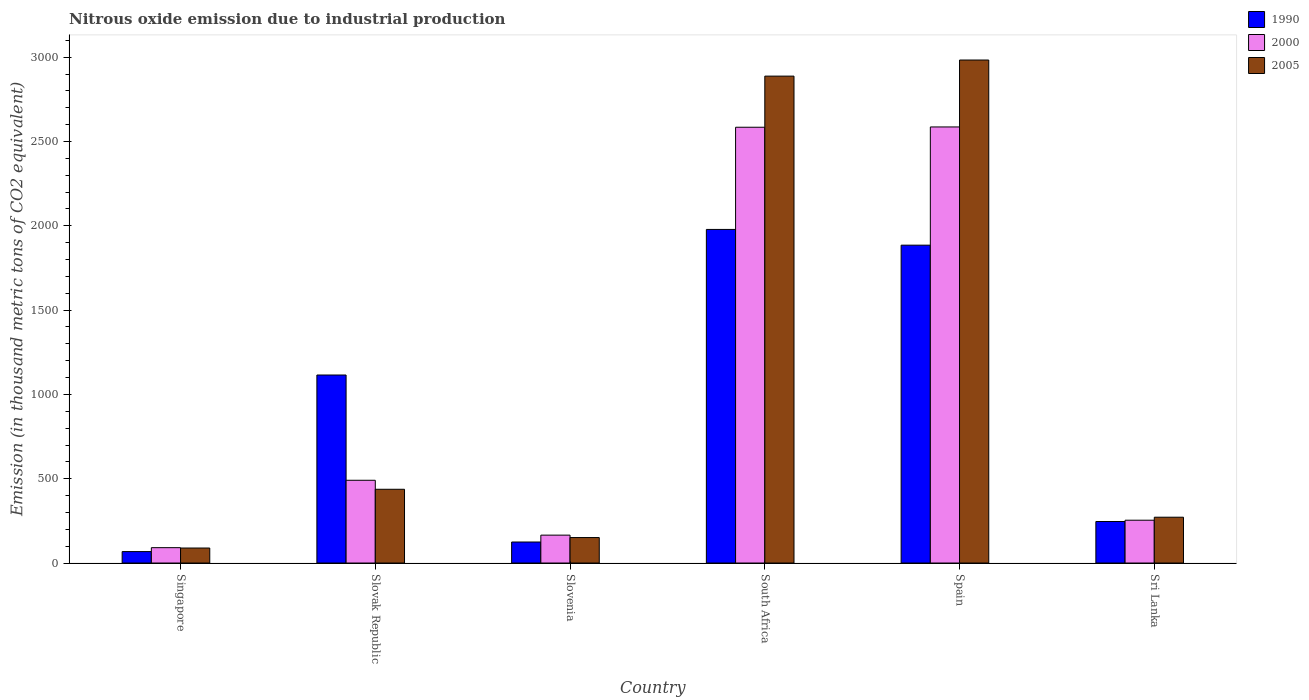How many groups of bars are there?
Provide a short and direct response. 6. Are the number of bars per tick equal to the number of legend labels?
Your response must be concise. Yes. How many bars are there on the 6th tick from the left?
Your response must be concise. 3. What is the label of the 3rd group of bars from the left?
Your response must be concise. Slovenia. In how many cases, is the number of bars for a given country not equal to the number of legend labels?
Offer a very short reply. 0. What is the amount of nitrous oxide emitted in 1990 in Slovenia?
Keep it short and to the point. 124.7. Across all countries, what is the maximum amount of nitrous oxide emitted in 2005?
Your answer should be very brief. 2983.4. Across all countries, what is the minimum amount of nitrous oxide emitted in 2005?
Make the answer very short. 89. In which country was the amount of nitrous oxide emitted in 1990 maximum?
Your answer should be compact. South Africa. In which country was the amount of nitrous oxide emitted in 2000 minimum?
Provide a succinct answer. Singapore. What is the total amount of nitrous oxide emitted in 2000 in the graph?
Offer a very short reply. 6172.6. What is the difference between the amount of nitrous oxide emitted in 2005 in Slovak Republic and that in Sri Lanka?
Your answer should be very brief. 165.7. What is the difference between the amount of nitrous oxide emitted in 2000 in South Africa and the amount of nitrous oxide emitted in 2005 in Spain?
Offer a very short reply. -398.7. What is the average amount of nitrous oxide emitted in 1990 per country?
Offer a terse response. 903. What is the ratio of the amount of nitrous oxide emitted in 2000 in South Africa to that in Sri Lanka?
Your answer should be very brief. 10.18. Is the amount of nitrous oxide emitted in 1990 in Singapore less than that in Slovenia?
Offer a terse response. Yes. What is the difference between the highest and the second highest amount of nitrous oxide emitted in 1990?
Make the answer very short. 863.4. What is the difference between the highest and the lowest amount of nitrous oxide emitted in 2005?
Provide a succinct answer. 2894.4. Is the sum of the amount of nitrous oxide emitted in 2000 in Slovenia and South Africa greater than the maximum amount of nitrous oxide emitted in 2005 across all countries?
Provide a succinct answer. No. What does the 3rd bar from the right in Sri Lanka represents?
Make the answer very short. 1990. How many bars are there?
Provide a short and direct response. 18. Are all the bars in the graph horizontal?
Ensure brevity in your answer.  No. How many countries are there in the graph?
Ensure brevity in your answer.  6. Are the values on the major ticks of Y-axis written in scientific E-notation?
Your answer should be compact. No. Does the graph contain any zero values?
Your answer should be very brief. No. Where does the legend appear in the graph?
Offer a terse response. Top right. How are the legend labels stacked?
Offer a terse response. Vertical. What is the title of the graph?
Offer a terse response. Nitrous oxide emission due to industrial production. What is the label or title of the Y-axis?
Make the answer very short. Emission (in thousand metric tons of CO2 equivalent). What is the Emission (in thousand metric tons of CO2 equivalent) in 1990 in Singapore?
Offer a very short reply. 67.9. What is the Emission (in thousand metric tons of CO2 equivalent) of 2000 in Singapore?
Give a very brief answer. 91.1. What is the Emission (in thousand metric tons of CO2 equivalent) in 2005 in Singapore?
Give a very brief answer. 89. What is the Emission (in thousand metric tons of CO2 equivalent) of 1990 in Slovak Republic?
Offer a terse response. 1115.2. What is the Emission (in thousand metric tons of CO2 equivalent) of 2000 in Slovak Republic?
Offer a terse response. 490.8. What is the Emission (in thousand metric tons of CO2 equivalent) in 2005 in Slovak Republic?
Keep it short and to the point. 437.5. What is the Emission (in thousand metric tons of CO2 equivalent) of 1990 in Slovenia?
Your answer should be very brief. 124.7. What is the Emission (in thousand metric tons of CO2 equivalent) of 2000 in Slovenia?
Make the answer very short. 165.5. What is the Emission (in thousand metric tons of CO2 equivalent) of 2005 in Slovenia?
Provide a succinct answer. 151.1. What is the Emission (in thousand metric tons of CO2 equivalent) of 1990 in South Africa?
Your response must be concise. 1978.6. What is the Emission (in thousand metric tons of CO2 equivalent) of 2000 in South Africa?
Give a very brief answer. 2584.7. What is the Emission (in thousand metric tons of CO2 equivalent) of 2005 in South Africa?
Make the answer very short. 2888. What is the Emission (in thousand metric tons of CO2 equivalent) in 1990 in Spain?
Your response must be concise. 1885.3. What is the Emission (in thousand metric tons of CO2 equivalent) of 2000 in Spain?
Your response must be concise. 2586.5. What is the Emission (in thousand metric tons of CO2 equivalent) of 2005 in Spain?
Your response must be concise. 2983.4. What is the Emission (in thousand metric tons of CO2 equivalent) in 1990 in Sri Lanka?
Offer a terse response. 246.3. What is the Emission (in thousand metric tons of CO2 equivalent) in 2000 in Sri Lanka?
Provide a short and direct response. 254. What is the Emission (in thousand metric tons of CO2 equivalent) of 2005 in Sri Lanka?
Provide a short and direct response. 271.8. Across all countries, what is the maximum Emission (in thousand metric tons of CO2 equivalent) in 1990?
Keep it short and to the point. 1978.6. Across all countries, what is the maximum Emission (in thousand metric tons of CO2 equivalent) in 2000?
Your answer should be very brief. 2586.5. Across all countries, what is the maximum Emission (in thousand metric tons of CO2 equivalent) of 2005?
Your answer should be compact. 2983.4. Across all countries, what is the minimum Emission (in thousand metric tons of CO2 equivalent) in 1990?
Provide a succinct answer. 67.9. Across all countries, what is the minimum Emission (in thousand metric tons of CO2 equivalent) of 2000?
Keep it short and to the point. 91.1. Across all countries, what is the minimum Emission (in thousand metric tons of CO2 equivalent) of 2005?
Give a very brief answer. 89. What is the total Emission (in thousand metric tons of CO2 equivalent) in 1990 in the graph?
Provide a short and direct response. 5418. What is the total Emission (in thousand metric tons of CO2 equivalent) in 2000 in the graph?
Keep it short and to the point. 6172.6. What is the total Emission (in thousand metric tons of CO2 equivalent) in 2005 in the graph?
Provide a short and direct response. 6820.8. What is the difference between the Emission (in thousand metric tons of CO2 equivalent) of 1990 in Singapore and that in Slovak Republic?
Make the answer very short. -1047.3. What is the difference between the Emission (in thousand metric tons of CO2 equivalent) of 2000 in Singapore and that in Slovak Republic?
Offer a terse response. -399.7. What is the difference between the Emission (in thousand metric tons of CO2 equivalent) in 2005 in Singapore and that in Slovak Republic?
Your answer should be very brief. -348.5. What is the difference between the Emission (in thousand metric tons of CO2 equivalent) of 1990 in Singapore and that in Slovenia?
Offer a very short reply. -56.8. What is the difference between the Emission (in thousand metric tons of CO2 equivalent) in 2000 in Singapore and that in Slovenia?
Give a very brief answer. -74.4. What is the difference between the Emission (in thousand metric tons of CO2 equivalent) of 2005 in Singapore and that in Slovenia?
Your response must be concise. -62.1. What is the difference between the Emission (in thousand metric tons of CO2 equivalent) in 1990 in Singapore and that in South Africa?
Your answer should be compact. -1910.7. What is the difference between the Emission (in thousand metric tons of CO2 equivalent) of 2000 in Singapore and that in South Africa?
Your response must be concise. -2493.6. What is the difference between the Emission (in thousand metric tons of CO2 equivalent) in 2005 in Singapore and that in South Africa?
Offer a terse response. -2799. What is the difference between the Emission (in thousand metric tons of CO2 equivalent) in 1990 in Singapore and that in Spain?
Make the answer very short. -1817.4. What is the difference between the Emission (in thousand metric tons of CO2 equivalent) in 2000 in Singapore and that in Spain?
Offer a very short reply. -2495.4. What is the difference between the Emission (in thousand metric tons of CO2 equivalent) in 2005 in Singapore and that in Spain?
Offer a very short reply. -2894.4. What is the difference between the Emission (in thousand metric tons of CO2 equivalent) of 1990 in Singapore and that in Sri Lanka?
Your response must be concise. -178.4. What is the difference between the Emission (in thousand metric tons of CO2 equivalent) in 2000 in Singapore and that in Sri Lanka?
Provide a succinct answer. -162.9. What is the difference between the Emission (in thousand metric tons of CO2 equivalent) in 2005 in Singapore and that in Sri Lanka?
Keep it short and to the point. -182.8. What is the difference between the Emission (in thousand metric tons of CO2 equivalent) of 1990 in Slovak Republic and that in Slovenia?
Give a very brief answer. 990.5. What is the difference between the Emission (in thousand metric tons of CO2 equivalent) in 2000 in Slovak Republic and that in Slovenia?
Keep it short and to the point. 325.3. What is the difference between the Emission (in thousand metric tons of CO2 equivalent) in 2005 in Slovak Republic and that in Slovenia?
Provide a short and direct response. 286.4. What is the difference between the Emission (in thousand metric tons of CO2 equivalent) in 1990 in Slovak Republic and that in South Africa?
Offer a terse response. -863.4. What is the difference between the Emission (in thousand metric tons of CO2 equivalent) in 2000 in Slovak Republic and that in South Africa?
Your response must be concise. -2093.9. What is the difference between the Emission (in thousand metric tons of CO2 equivalent) of 2005 in Slovak Republic and that in South Africa?
Offer a terse response. -2450.5. What is the difference between the Emission (in thousand metric tons of CO2 equivalent) of 1990 in Slovak Republic and that in Spain?
Offer a very short reply. -770.1. What is the difference between the Emission (in thousand metric tons of CO2 equivalent) in 2000 in Slovak Republic and that in Spain?
Ensure brevity in your answer.  -2095.7. What is the difference between the Emission (in thousand metric tons of CO2 equivalent) of 2005 in Slovak Republic and that in Spain?
Offer a terse response. -2545.9. What is the difference between the Emission (in thousand metric tons of CO2 equivalent) in 1990 in Slovak Republic and that in Sri Lanka?
Your answer should be compact. 868.9. What is the difference between the Emission (in thousand metric tons of CO2 equivalent) of 2000 in Slovak Republic and that in Sri Lanka?
Make the answer very short. 236.8. What is the difference between the Emission (in thousand metric tons of CO2 equivalent) in 2005 in Slovak Republic and that in Sri Lanka?
Your response must be concise. 165.7. What is the difference between the Emission (in thousand metric tons of CO2 equivalent) in 1990 in Slovenia and that in South Africa?
Provide a short and direct response. -1853.9. What is the difference between the Emission (in thousand metric tons of CO2 equivalent) of 2000 in Slovenia and that in South Africa?
Provide a succinct answer. -2419.2. What is the difference between the Emission (in thousand metric tons of CO2 equivalent) in 2005 in Slovenia and that in South Africa?
Give a very brief answer. -2736.9. What is the difference between the Emission (in thousand metric tons of CO2 equivalent) of 1990 in Slovenia and that in Spain?
Offer a terse response. -1760.6. What is the difference between the Emission (in thousand metric tons of CO2 equivalent) in 2000 in Slovenia and that in Spain?
Keep it short and to the point. -2421. What is the difference between the Emission (in thousand metric tons of CO2 equivalent) of 2005 in Slovenia and that in Spain?
Provide a succinct answer. -2832.3. What is the difference between the Emission (in thousand metric tons of CO2 equivalent) in 1990 in Slovenia and that in Sri Lanka?
Your response must be concise. -121.6. What is the difference between the Emission (in thousand metric tons of CO2 equivalent) of 2000 in Slovenia and that in Sri Lanka?
Give a very brief answer. -88.5. What is the difference between the Emission (in thousand metric tons of CO2 equivalent) in 2005 in Slovenia and that in Sri Lanka?
Your response must be concise. -120.7. What is the difference between the Emission (in thousand metric tons of CO2 equivalent) of 1990 in South Africa and that in Spain?
Make the answer very short. 93.3. What is the difference between the Emission (in thousand metric tons of CO2 equivalent) of 2005 in South Africa and that in Spain?
Ensure brevity in your answer.  -95.4. What is the difference between the Emission (in thousand metric tons of CO2 equivalent) of 1990 in South Africa and that in Sri Lanka?
Give a very brief answer. 1732.3. What is the difference between the Emission (in thousand metric tons of CO2 equivalent) of 2000 in South Africa and that in Sri Lanka?
Offer a terse response. 2330.7. What is the difference between the Emission (in thousand metric tons of CO2 equivalent) of 2005 in South Africa and that in Sri Lanka?
Offer a terse response. 2616.2. What is the difference between the Emission (in thousand metric tons of CO2 equivalent) in 1990 in Spain and that in Sri Lanka?
Your response must be concise. 1639. What is the difference between the Emission (in thousand metric tons of CO2 equivalent) of 2000 in Spain and that in Sri Lanka?
Your response must be concise. 2332.5. What is the difference between the Emission (in thousand metric tons of CO2 equivalent) in 2005 in Spain and that in Sri Lanka?
Keep it short and to the point. 2711.6. What is the difference between the Emission (in thousand metric tons of CO2 equivalent) of 1990 in Singapore and the Emission (in thousand metric tons of CO2 equivalent) of 2000 in Slovak Republic?
Offer a very short reply. -422.9. What is the difference between the Emission (in thousand metric tons of CO2 equivalent) in 1990 in Singapore and the Emission (in thousand metric tons of CO2 equivalent) in 2005 in Slovak Republic?
Provide a short and direct response. -369.6. What is the difference between the Emission (in thousand metric tons of CO2 equivalent) of 2000 in Singapore and the Emission (in thousand metric tons of CO2 equivalent) of 2005 in Slovak Republic?
Your response must be concise. -346.4. What is the difference between the Emission (in thousand metric tons of CO2 equivalent) of 1990 in Singapore and the Emission (in thousand metric tons of CO2 equivalent) of 2000 in Slovenia?
Your response must be concise. -97.6. What is the difference between the Emission (in thousand metric tons of CO2 equivalent) of 1990 in Singapore and the Emission (in thousand metric tons of CO2 equivalent) of 2005 in Slovenia?
Make the answer very short. -83.2. What is the difference between the Emission (in thousand metric tons of CO2 equivalent) of 2000 in Singapore and the Emission (in thousand metric tons of CO2 equivalent) of 2005 in Slovenia?
Your response must be concise. -60. What is the difference between the Emission (in thousand metric tons of CO2 equivalent) of 1990 in Singapore and the Emission (in thousand metric tons of CO2 equivalent) of 2000 in South Africa?
Give a very brief answer. -2516.8. What is the difference between the Emission (in thousand metric tons of CO2 equivalent) in 1990 in Singapore and the Emission (in thousand metric tons of CO2 equivalent) in 2005 in South Africa?
Provide a succinct answer. -2820.1. What is the difference between the Emission (in thousand metric tons of CO2 equivalent) of 2000 in Singapore and the Emission (in thousand metric tons of CO2 equivalent) of 2005 in South Africa?
Your response must be concise. -2796.9. What is the difference between the Emission (in thousand metric tons of CO2 equivalent) of 1990 in Singapore and the Emission (in thousand metric tons of CO2 equivalent) of 2000 in Spain?
Keep it short and to the point. -2518.6. What is the difference between the Emission (in thousand metric tons of CO2 equivalent) of 1990 in Singapore and the Emission (in thousand metric tons of CO2 equivalent) of 2005 in Spain?
Your response must be concise. -2915.5. What is the difference between the Emission (in thousand metric tons of CO2 equivalent) in 2000 in Singapore and the Emission (in thousand metric tons of CO2 equivalent) in 2005 in Spain?
Give a very brief answer. -2892.3. What is the difference between the Emission (in thousand metric tons of CO2 equivalent) of 1990 in Singapore and the Emission (in thousand metric tons of CO2 equivalent) of 2000 in Sri Lanka?
Your answer should be compact. -186.1. What is the difference between the Emission (in thousand metric tons of CO2 equivalent) of 1990 in Singapore and the Emission (in thousand metric tons of CO2 equivalent) of 2005 in Sri Lanka?
Your answer should be very brief. -203.9. What is the difference between the Emission (in thousand metric tons of CO2 equivalent) in 2000 in Singapore and the Emission (in thousand metric tons of CO2 equivalent) in 2005 in Sri Lanka?
Your answer should be very brief. -180.7. What is the difference between the Emission (in thousand metric tons of CO2 equivalent) of 1990 in Slovak Republic and the Emission (in thousand metric tons of CO2 equivalent) of 2000 in Slovenia?
Make the answer very short. 949.7. What is the difference between the Emission (in thousand metric tons of CO2 equivalent) of 1990 in Slovak Republic and the Emission (in thousand metric tons of CO2 equivalent) of 2005 in Slovenia?
Your response must be concise. 964.1. What is the difference between the Emission (in thousand metric tons of CO2 equivalent) of 2000 in Slovak Republic and the Emission (in thousand metric tons of CO2 equivalent) of 2005 in Slovenia?
Keep it short and to the point. 339.7. What is the difference between the Emission (in thousand metric tons of CO2 equivalent) in 1990 in Slovak Republic and the Emission (in thousand metric tons of CO2 equivalent) in 2000 in South Africa?
Keep it short and to the point. -1469.5. What is the difference between the Emission (in thousand metric tons of CO2 equivalent) in 1990 in Slovak Republic and the Emission (in thousand metric tons of CO2 equivalent) in 2005 in South Africa?
Your response must be concise. -1772.8. What is the difference between the Emission (in thousand metric tons of CO2 equivalent) in 2000 in Slovak Republic and the Emission (in thousand metric tons of CO2 equivalent) in 2005 in South Africa?
Your response must be concise. -2397.2. What is the difference between the Emission (in thousand metric tons of CO2 equivalent) in 1990 in Slovak Republic and the Emission (in thousand metric tons of CO2 equivalent) in 2000 in Spain?
Your answer should be compact. -1471.3. What is the difference between the Emission (in thousand metric tons of CO2 equivalent) of 1990 in Slovak Republic and the Emission (in thousand metric tons of CO2 equivalent) of 2005 in Spain?
Keep it short and to the point. -1868.2. What is the difference between the Emission (in thousand metric tons of CO2 equivalent) in 2000 in Slovak Republic and the Emission (in thousand metric tons of CO2 equivalent) in 2005 in Spain?
Keep it short and to the point. -2492.6. What is the difference between the Emission (in thousand metric tons of CO2 equivalent) of 1990 in Slovak Republic and the Emission (in thousand metric tons of CO2 equivalent) of 2000 in Sri Lanka?
Keep it short and to the point. 861.2. What is the difference between the Emission (in thousand metric tons of CO2 equivalent) of 1990 in Slovak Republic and the Emission (in thousand metric tons of CO2 equivalent) of 2005 in Sri Lanka?
Provide a short and direct response. 843.4. What is the difference between the Emission (in thousand metric tons of CO2 equivalent) in 2000 in Slovak Republic and the Emission (in thousand metric tons of CO2 equivalent) in 2005 in Sri Lanka?
Your response must be concise. 219. What is the difference between the Emission (in thousand metric tons of CO2 equivalent) in 1990 in Slovenia and the Emission (in thousand metric tons of CO2 equivalent) in 2000 in South Africa?
Make the answer very short. -2460. What is the difference between the Emission (in thousand metric tons of CO2 equivalent) of 1990 in Slovenia and the Emission (in thousand metric tons of CO2 equivalent) of 2005 in South Africa?
Provide a short and direct response. -2763.3. What is the difference between the Emission (in thousand metric tons of CO2 equivalent) in 2000 in Slovenia and the Emission (in thousand metric tons of CO2 equivalent) in 2005 in South Africa?
Make the answer very short. -2722.5. What is the difference between the Emission (in thousand metric tons of CO2 equivalent) of 1990 in Slovenia and the Emission (in thousand metric tons of CO2 equivalent) of 2000 in Spain?
Your answer should be compact. -2461.8. What is the difference between the Emission (in thousand metric tons of CO2 equivalent) in 1990 in Slovenia and the Emission (in thousand metric tons of CO2 equivalent) in 2005 in Spain?
Make the answer very short. -2858.7. What is the difference between the Emission (in thousand metric tons of CO2 equivalent) of 2000 in Slovenia and the Emission (in thousand metric tons of CO2 equivalent) of 2005 in Spain?
Make the answer very short. -2817.9. What is the difference between the Emission (in thousand metric tons of CO2 equivalent) of 1990 in Slovenia and the Emission (in thousand metric tons of CO2 equivalent) of 2000 in Sri Lanka?
Give a very brief answer. -129.3. What is the difference between the Emission (in thousand metric tons of CO2 equivalent) in 1990 in Slovenia and the Emission (in thousand metric tons of CO2 equivalent) in 2005 in Sri Lanka?
Offer a very short reply. -147.1. What is the difference between the Emission (in thousand metric tons of CO2 equivalent) of 2000 in Slovenia and the Emission (in thousand metric tons of CO2 equivalent) of 2005 in Sri Lanka?
Offer a very short reply. -106.3. What is the difference between the Emission (in thousand metric tons of CO2 equivalent) in 1990 in South Africa and the Emission (in thousand metric tons of CO2 equivalent) in 2000 in Spain?
Offer a terse response. -607.9. What is the difference between the Emission (in thousand metric tons of CO2 equivalent) in 1990 in South Africa and the Emission (in thousand metric tons of CO2 equivalent) in 2005 in Spain?
Make the answer very short. -1004.8. What is the difference between the Emission (in thousand metric tons of CO2 equivalent) of 2000 in South Africa and the Emission (in thousand metric tons of CO2 equivalent) of 2005 in Spain?
Your answer should be very brief. -398.7. What is the difference between the Emission (in thousand metric tons of CO2 equivalent) in 1990 in South Africa and the Emission (in thousand metric tons of CO2 equivalent) in 2000 in Sri Lanka?
Your response must be concise. 1724.6. What is the difference between the Emission (in thousand metric tons of CO2 equivalent) in 1990 in South Africa and the Emission (in thousand metric tons of CO2 equivalent) in 2005 in Sri Lanka?
Provide a succinct answer. 1706.8. What is the difference between the Emission (in thousand metric tons of CO2 equivalent) of 2000 in South Africa and the Emission (in thousand metric tons of CO2 equivalent) of 2005 in Sri Lanka?
Provide a short and direct response. 2312.9. What is the difference between the Emission (in thousand metric tons of CO2 equivalent) in 1990 in Spain and the Emission (in thousand metric tons of CO2 equivalent) in 2000 in Sri Lanka?
Provide a short and direct response. 1631.3. What is the difference between the Emission (in thousand metric tons of CO2 equivalent) in 1990 in Spain and the Emission (in thousand metric tons of CO2 equivalent) in 2005 in Sri Lanka?
Ensure brevity in your answer.  1613.5. What is the difference between the Emission (in thousand metric tons of CO2 equivalent) in 2000 in Spain and the Emission (in thousand metric tons of CO2 equivalent) in 2005 in Sri Lanka?
Make the answer very short. 2314.7. What is the average Emission (in thousand metric tons of CO2 equivalent) of 1990 per country?
Provide a succinct answer. 903. What is the average Emission (in thousand metric tons of CO2 equivalent) in 2000 per country?
Keep it short and to the point. 1028.77. What is the average Emission (in thousand metric tons of CO2 equivalent) in 2005 per country?
Give a very brief answer. 1136.8. What is the difference between the Emission (in thousand metric tons of CO2 equivalent) of 1990 and Emission (in thousand metric tons of CO2 equivalent) of 2000 in Singapore?
Keep it short and to the point. -23.2. What is the difference between the Emission (in thousand metric tons of CO2 equivalent) of 1990 and Emission (in thousand metric tons of CO2 equivalent) of 2005 in Singapore?
Make the answer very short. -21.1. What is the difference between the Emission (in thousand metric tons of CO2 equivalent) in 2000 and Emission (in thousand metric tons of CO2 equivalent) in 2005 in Singapore?
Your answer should be very brief. 2.1. What is the difference between the Emission (in thousand metric tons of CO2 equivalent) in 1990 and Emission (in thousand metric tons of CO2 equivalent) in 2000 in Slovak Republic?
Keep it short and to the point. 624.4. What is the difference between the Emission (in thousand metric tons of CO2 equivalent) of 1990 and Emission (in thousand metric tons of CO2 equivalent) of 2005 in Slovak Republic?
Offer a very short reply. 677.7. What is the difference between the Emission (in thousand metric tons of CO2 equivalent) in 2000 and Emission (in thousand metric tons of CO2 equivalent) in 2005 in Slovak Republic?
Ensure brevity in your answer.  53.3. What is the difference between the Emission (in thousand metric tons of CO2 equivalent) of 1990 and Emission (in thousand metric tons of CO2 equivalent) of 2000 in Slovenia?
Make the answer very short. -40.8. What is the difference between the Emission (in thousand metric tons of CO2 equivalent) of 1990 and Emission (in thousand metric tons of CO2 equivalent) of 2005 in Slovenia?
Offer a very short reply. -26.4. What is the difference between the Emission (in thousand metric tons of CO2 equivalent) in 2000 and Emission (in thousand metric tons of CO2 equivalent) in 2005 in Slovenia?
Ensure brevity in your answer.  14.4. What is the difference between the Emission (in thousand metric tons of CO2 equivalent) in 1990 and Emission (in thousand metric tons of CO2 equivalent) in 2000 in South Africa?
Provide a short and direct response. -606.1. What is the difference between the Emission (in thousand metric tons of CO2 equivalent) of 1990 and Emission (in thousand metric tons of CO2 equivalent) of 2005 in South Africa?
Provide a succinct answer. -909.4. What is the difference between the Emission (in thousand metric tons of CO2 equivalent) of 2000 and Emission (in thousand metric tons of CO2 equivalent) of 2005 in South Africa?
Your answer should be compact. -303.3. What is the difference between the Emission (in thousand metric tons of CO2 equivalent) in 1990 and Emission (in thousand metric tons of CO2 equivalent) in 2000 in Spain?
Your answer should be compact. -701.2. What is the difference between the Emission (in thousand metric tons of CO2 equivalent) of 1990 and Emission (in thousand metric tons of CO2 equivalent) of 2005 in Spain?
Offer a terse response. -1098.1. What is the difference between the Emission (in thousand metric tons of CO2 equivalent) in 2000 and Emission (in thousand metric tons of CO2 equivalent) in 2005 in Spain?
Keep it short and to the point. -396.9. What is the difference between the Emission (in thousand metric tons of CO2 equivalent) in 1990 and Emission (in thousand metric tons of CO2 equivalent) in 2000 in Sri Lanka?
Your answer should be very brief. -7.7. What is the difference between the Emission (in thousand metric tons of CO2 equivalent) of 1990 and Emission (in thousand metric tons of CO2 equivalent) of 2005 in Sri Lanka?
Your response must be concise. -25.5. What is the difference between the Emission (in thousand metric tons of CO2 equivalent) of 2000 and Emission (in thousand metric tons of CO2 equivalent) of 2005 in Sri Lanka?
Your response must be concise. -17.8. What is the ratio of the Emission (in thousand metric tons of CO2 equivalent) in 1990 in Singapore to that in Slovak Republic?
Provide a succinct answer. 0.06. What is the ratio of the Emission (in thousand metric tons of CO2 equivalent) in 2000 in Singapore to that in Slovak Republic?
Your response must be concise. 0.19. What is the ratio of the Emission (in thousand metric tons of CO2 equivalent) in 2005 in Singapore to that in Slovak Republic?
Provide a succinct answer. 0.2. What is the ratio of the Emission (in thousand metric tons of CO2 equivalent) in 1990 in Singapore to that in Slovenia?
Offer a terse response. 0.54. What is the ratio of the Emission (in thousand metric tons of CO2 equivalent) of 2000 in Singapore to that in Slovenia?
Your response must be concise. 0.55. What is the ratio of the Emission (in thousand metric tons of CO2 equivalent) in 2005 in Singapore to that in Slovenia?
Keep it short and to the point. 0.59. What is the ratio of the Emission (in thousand metric tons of CO2 equivalent) in 1990 in Singapore to that in South Africa?
Your answer should be very brief. 0.03. What is the ratio of the Emission (in thousand metric tons of CO2 equivalent) in 2000 in Singapore to that in South Africa?
Offer a terse response. 0.04. What is the ratio of the Emission (in thousand metric tons of CO2 equivalent) of 2005 in Singapore to that in South Africa?
Keep it short and to the point. 0.03. What is the ratio of the Emission (in thousand metric tons of CO2 equivalent) of 1990 in Singapore to that in Spain?
Your answer should be very brief. 0.04. What is the ratio of the Emission (in thousand metric tons of CO2 equivalent) in 2000 in Singapore to that in Spain?
Your response must be concise. 0.04. What is the ratio of the Emission (in thousand metric tons of CO2 equivalent) of 2005 in Singapore to that in Spain?
Give a very brief answer. 0.03. What is the ratio of the Emission (in thousand metric tons of CO2 equivalent) of 1990 in Singapore to that in Sri Lanka?
Provide a succinct answer. 0.28. What is the ratio of the Emission (in thousand metric tons of CO2 equivalent) in 2000 in Singapore to that in Sri Lanka?
Make the answer very short. 0.36. What is the ratio of the Emission (in thousand metric tons of CO2 equivalent) of 2005 in Singapore to that in Sri Lanka?
Give a very brief answer. 0.33. What is the ratio of the Emission (in thousand metric tons of CO2 equivalent) of 1990 in Slovak Republic to that in Slovenia?
Give a very brief answer. 8.94. What is the ratio of the Emission (in thousand metric tons of CO2 equivalent) in 2000 in Slovak Republic to that in Slovenia?
Offer a terse response. 2.97. What is the ratio of the Emission (in thousand metric tons of CO2 equivalent) in 2005 in Slovak Republic to that in Slovenia?
Provide a succinct answer. 2.9. What is the ratio of the Emission (in thousand metric tons of CO2 equivalent) of 1990 in Slovak Republic to that in South Africa?
Offer a terse response. 0.56. What is the ratio of the Emission (in thousand metric tons of CO2 equivalent) of 2000 in Slovak Republic to that in South Africa?
Give a very brief answer. 0.19. What is the ratio of the Emission (in thousand metric tons of CO2 equivalent) of 2005 in Slovak Republic to that in South Africa?
Provide a succinct answer. 0.15. What is the ratio of the Emission (in thousand metric tons of CO2 equivalent) in 1990 in Slovak Republic to that in Spain?
Provide a succinct answer. 0.59. What is the ratio of the Emission (in thousand metric tons of CO2 equivalent) of 2000 in Slovak Republic to that in Spain?
Offer a very short reply. 0.19. What is the ratio of the Emission (in thousand metric tons of CO2 equivalent) in 2005 in Slovak Republic to that in Spain?
Provide a succinct answer. 0.15. What is the ratio of the Emission (in thousand metric tons of CO2 equivalent) in 1990 in Slovak Republic to that in Sri Lanka?
Your answer should be very brief. 4.53. What is the ratio of the Emission (in thousand metric tons of CO2 equivalent) in 2000 in Slovak Republic to that in Sri Lanka?
Your answer should be very brief. 1.93. What is the ratio of the Emission (in thousand metric tons of CO2 equivalent) in 2005 in Slovak Republic to that in Sri Lanka?
Ensure brevity in your answer.  1.61. What is the ratio of the Emission (in thousand metric tons of CO2 equivalent) in 1990 in Slovenia to that in South Africa?
Your response must be concise. 0.06. What is the ratio of the Emission (in thousand metric tons of CO2 equivalent) in 2000 in Slovenia to that in South Africa?
Make the answer very short. 0.06. What is the ratio of the Emission (in thousand metric tons of CO2 equivalent) in 2005 in Slovenia to that in South Africa?
Your answer should be compact. 0.05. What is the ratio of the Emission (in thousand metric tons of CO2 equivalent) in 1990 in Slovenia to that in Spain?
Your answer should be very brief. 0.07. What is the ratio of the Emission (in thousand metric tons of CO2 equivalent) of 2000 in Slovenia to that in Spain?
Your answer should be compact. 0.06. What is the ratio of the Emission (in thousand metric tons of CO2 equivalent) of 2005 in Slovenia to that in Spain?
Ensure brevity in your answer.  0.05. What is the ratio of the Emission (in thousand metric tons of CO2 equivalent) of 1990 in Slovenia to that in Sri Lanka?
Keep it short and to the point. 0.51. What is the ratio of the Emission (in thousand metric tons of CO2 equivalent) in 2000 in Slovenia to that in Sri Lanka?
Provide a succinct answer. 0.65. What is the ratio of the Emission (in thousand metric tons of CO2 equivalent) in 2005 in Slovenia to that in Sri Lanka?
Your answer should be very brief. 0.56. What is the ratio of the Emission (in thousand metric tons of CO2 equivalent) of 1990 in South Africa to that in Spain?
Make the answer very short. 1.05. What is the ratio of the Emission (in thousand metric tons of CO2 equivalent) of 1990 in South Africa to that in Sri Lanka?
Make the answer very short. 8.03. What is the ratio of the Emission (in thousand metric tons of CO2 equivalent) of 2000 in South Africa to that in Sri Lanka?
Your answer should be very brief. 10.18. What is the ratio of the Emission (in thousand metric tons of CO2 equivalent) of 2005 in South Africa to that in Sri Lanka?
Offer a terse response. 10.63. What is the ratio of the Emission (in thousand metric tons of CO2 equivalent) in 1990 in Spain to that in Sri Lanka?
Ensure brevity in your answer.  7.65. What is the ratio of the Emission (in thousand metric tons of CO2 equivalent) of 2000 in Spain to that in Sri Lanka?
Make the answer very short. 10.18. What is the ratio of the Emission (in thousand metric tons of CO2 equivalent) of 2005 in Spain to that in Sri Lanka?
Make the answer very short. 10.98. What is the difference between the highest and the second highest Emission (in thousand metric tons of CO2 equivalent) of 1990?
Offer a terse response. 93.3. What is the difference between the highest and the second highest Emission (in thousand metric tons of CO2 equivalent) of 2000?
Your response must be concise. 1.8. What is the difference between the highest and the second highest Emission (in thousand metric tons of CO2 equivalent) of 2005?
Provide a succinct answer. 95.4. What is the difference between the highest and the lowest Emission (in thousand metric tons of CO2 equivalent) of 1990?
Keep it short and to the point. 1910.7. What is the difference between the highest and the lowest Emission (in thousand metric tons of CO2 equivalent) in 2000?
Your answer should be compact. 2495.4. What is the difference between the highest and the lowest Emission (in thousand metric tons of CO2 equivalent) of 2005?
Provide a succinct answer. 2894.4. 